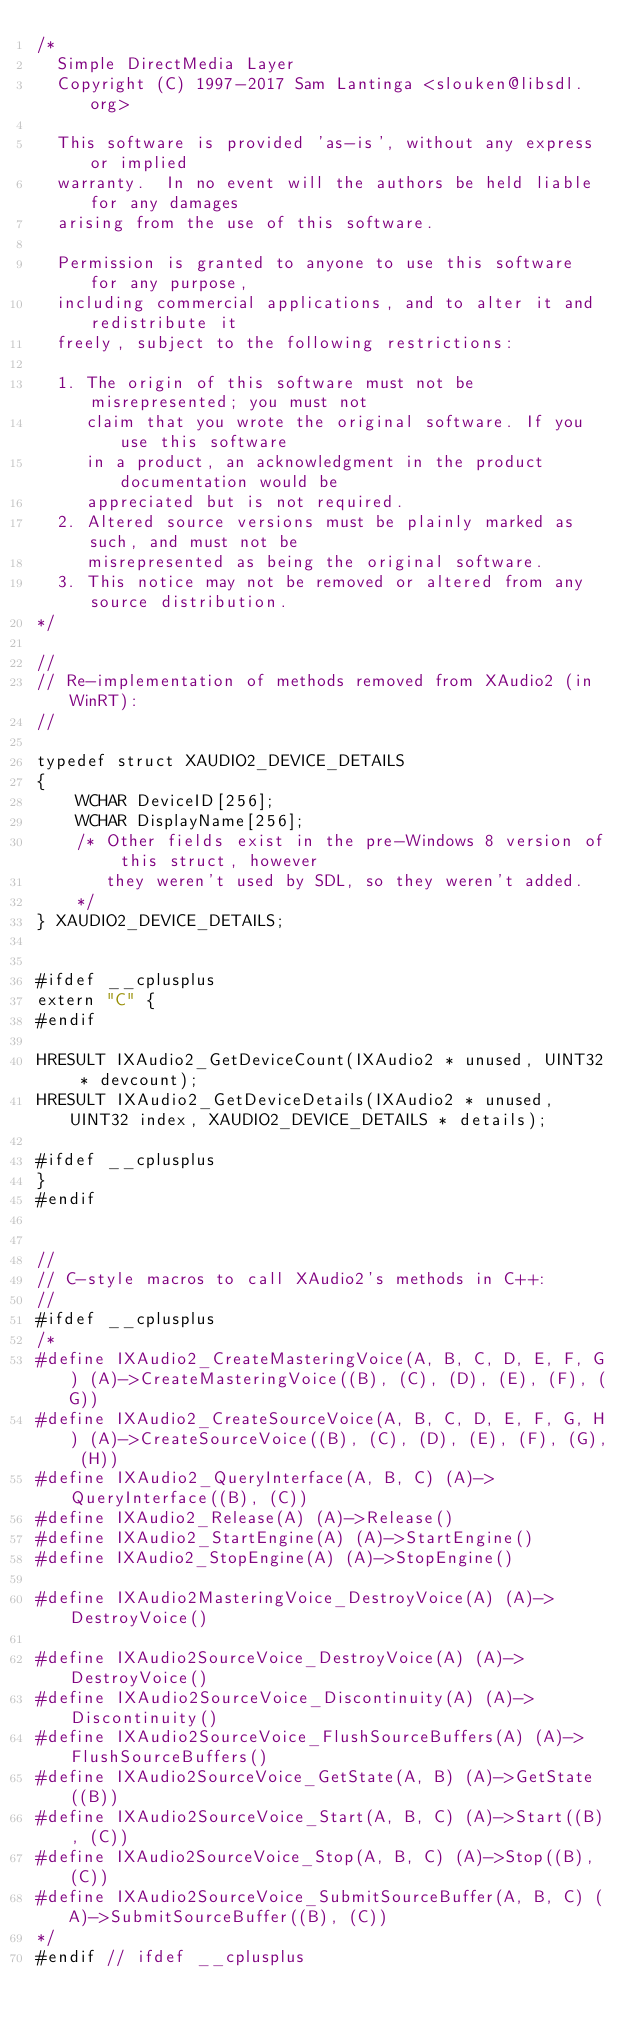Convert code to text. <code><loc_0><loc_0><loc_500><loc_500><_C_>/*
  Simple DirectMedia Layer
  Copyright (C) 1997-2017 Sam Lantinga <slouken@libsdl.org>

  This software is provided 'as-is', without any express or implied
  warranty.  In no event will the authors be held liable for any damages
  arising from the use of this software.

  Permission is granted to anyone to use this software for any purpose,
  including commercial applications, and to alter it and redistribute it
  freely, subject to the following restrictions:

  1. The origin of this software must not be misrepresented; you must not
     claim that you wrote the original software. If you use this software
     in a product, an acknowledgment in the product documentation would be
     appreciated but is not required.
  2. Altered source versions must be plainly marked as such, and must not be
     misrepresented as being the original software.
  3. This notice may not be removed or altered from any source distribution.
*/

//
// Re-implementation of methods removed from XAudio2 (in WinRT):
//

typedef struct XAUDIO2_DEVICE_DETAILS
{
    WCHAR DeviceID[256];
    WCHAR DisplayName[256];
    /* Other fields exist in the pre-Windows 8 version of this struct, however
       they weren't used by SDL, so they weren't added.
    */
} XAUDIO2_DEVICE_DETAILS;


#ifdef __cplusplus
extern "C" {
#endif

HRESULT IXAudio2_GetDeviceCount(IXAudio2 * unused, UINT32 * devcount);
HRESULT IXAudio2_GetDeviceDetails(IXAudio2 * unused, UINT32 index, XAUDIO2_DEVICE_DETAILS * details);

#ifdef __cplusplus
}
#endif


//
// C-style macros to call XAudio2's methods in C++:
//
#ifdef __cplusplus
/*
#define IXAudio2_CreateMasteringVoice(A, B, C, D, E, F, G) (A)->CreateMasteringVoice((B), (C), (D), (E), (F), (G))
#define IXAudio2_CreateSourceVoice(A, B, C, D, E, F, G, H) (A)->CreateSourceVoice((B), (C), (D), (E), (F), (G), (H))
#define IXAudio2_QueryInterface(A, B, C) (A)->QueryInterface((B), (C))
#define IXAudio2_Release(A) (A)->Release()
#define IXAudio2_StartEngine(A) (A)->StartEngine()
#define IXAudio2_StopEngine(A) (A)->StopEngine()

#define IXAudio2MasteringVoice_DestroyVoice(A) (A)->DestroyVoice()

#define IXAudio2SourceVoice_DestroyVoice(A) (A)->DestroyVoice()
#define IXAudio2SourceVoice_Discontinuity(A) (A)->Discontinuity()
#define IXAudio2SourceVoice_FlushSourceBuffers(A) (A)->FlushSourceBuffers()
#define IXAudio2SourceVoice_GetState(A, B) (A)->GetState((B))
#define IXAudio2SourceVoice_Start(A, B, C) (A)->Start((B), (C))
#define IXAudio2SourceVoice_Stop(A, B, C) (A)->Stop((B), (C))
#define IXAudio2SourceVoice_SubmitSourceBuffer(A, B, C) (A)->SubmitSourceBuffer((B), (C))
*/
#endif // ifdef __cplusplus
</code> 